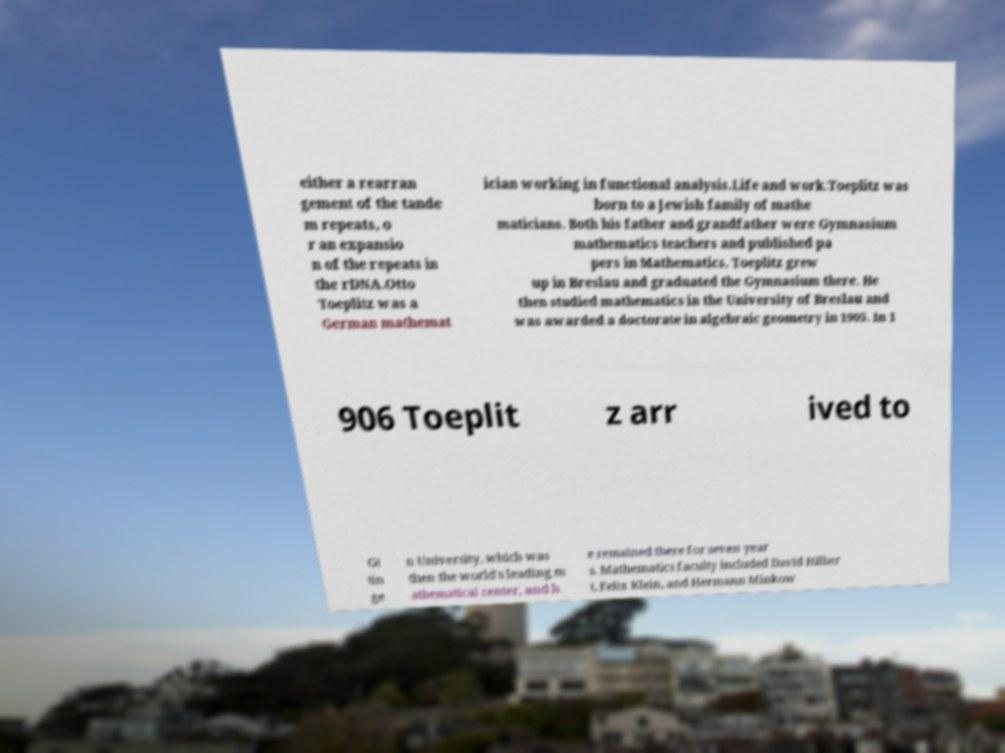Can you accurately transcribe the text from the provided image for me? either a rearran gement of the tande m repeats, o r an expansio n of the repeats in the rDNA.Otto Toeplitz was a German mathemat ician working in functional analysis.Life and work.Toeplitz was born to a Jewish family of mathe maticians. Both his father and grandfather were Gymnasium mathematics teachers and published pa pers in Mathematics. Toeplitz grew up in Breslau and graduated the Gymnasium there. He then studied mathematics in the University of Breslau and was awarded a doctorate in algebraic geometry in 1905. In 1 906 Toeplit z arr ived to Gt tin ge n University, which was then the world's leading m athematical center, and h e remained there for seven year s. Mathematics faculty included David Hilber t, Felix Klein, and Hermann Minkow 